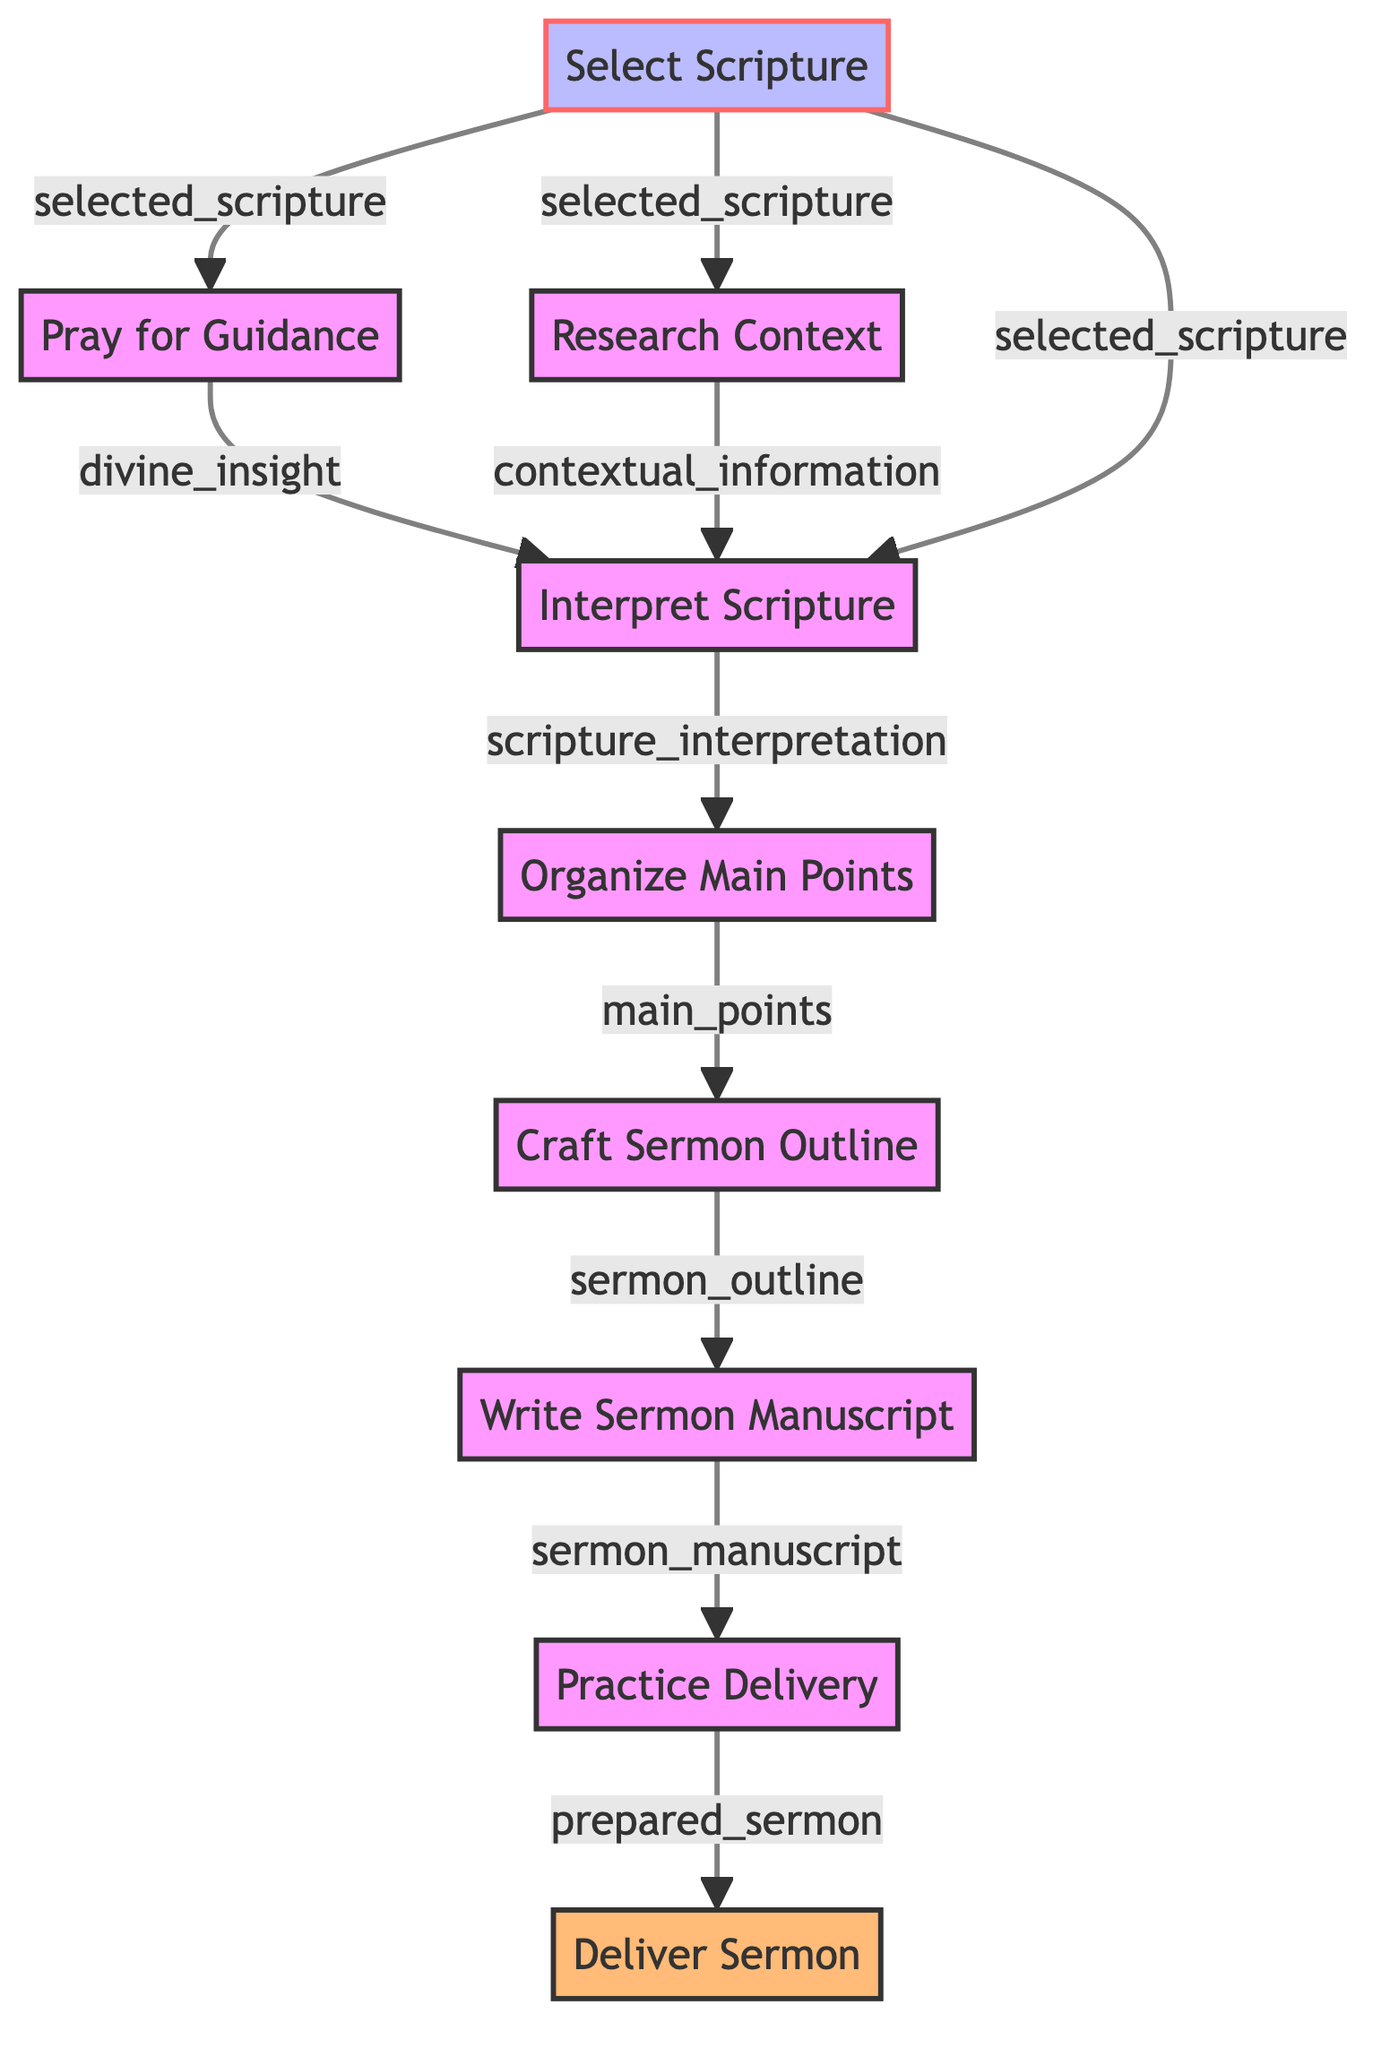What is the first step in preparing a sermon? The first step in the diagram is "Select Scripture," which is the initial action to identify a biblical passage for the sermon.
Answer: Select Scripture How many nodes are there in this flowchart? The flowchart features a total of 9 nodes, each representing a distinct step in the sermon preparation process.
Answer: 9 What is the output of the "Deliver Sermon" step? The output of the "Deliver Sermon" step is "delivered_sermon," which indicates the final product of the sermon preparation process.
Answer: delivered_sermon Which step requires input from both "Research Context" and "Pray for Guidance"? The "Interpret Scripture" step requires input from both "Research Context" (provides contextual information) and "Pray for Guidance" (provides divine insight) to analyze the scripture meaningfully.
Answer: Interpret Scripture What output do you receive after "Write Sermon Manuscript"? After "Write Sermon Manuscript," the output is "prepared_sermon," which is the result of the manuscript writing process.
Answer: prepared_sermon Which step directly follows "Craft Sermon Outline"? The step that directly follows "Craft Sermon Outline" is "Write Sermon Manuscript," indicating that a structured outline leads to a detailed manuscript.
Answer: Write Sermon Manuscript What inputs are needed to "Organize Main Points"? To "Organize Main Points," the input required is "scripture_interpretation," meaning the main points are based on the interpretation of the scripture.
Answer: scripture_interpretation What is the relationship between "Select Scripture" and "Research Context"? "Select Scripture" serves as a direct input for "Research Context," meaning that the scripture selection is essential for the context research.
Answer: input 